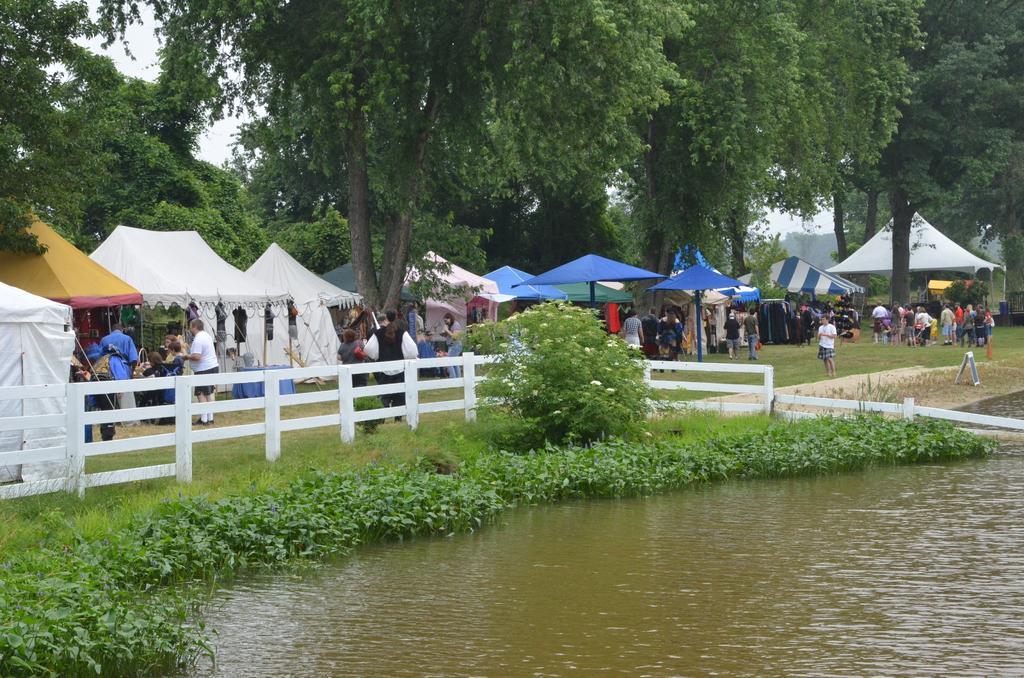Describe this image in one or two sentences. In this image I can see water, grass, number of tents, number of trees and here I can see number of people are standing. 